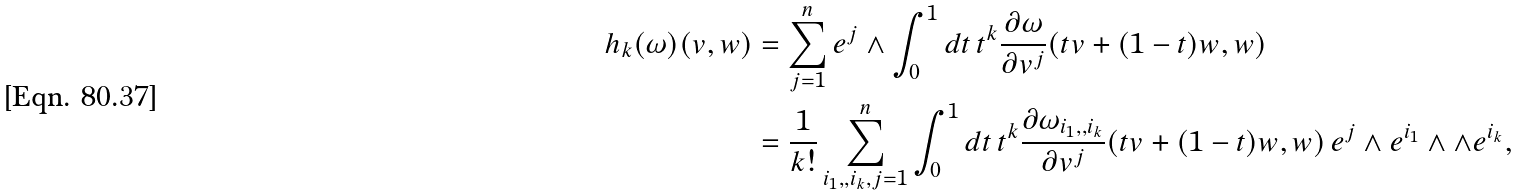Convert formula to latex. <formula><loc_0><loc_0><loc_500><loc_500>h _ { k } ( \omega ) ( v , w ) & = \sum _ { j = 1 } ^ { n } e ^ { j } \wedge \int _ { 0 } ^ { 1 } d t \, t ^ { k } \frac { \partial \omega } { \partial v ^ { j } } ( t v + ( 1 - t ) w , w ) \\ & = \frac { 1 } { k ! } \sum _ { i _ { 1 } , , i _ { k } , j = 1 } ^ { n } \int _ { 0 } ^ { 1 } d t \, t ^ { k } \frac { \partial \omega _ { i _ { 1 } , , i _ { k } } } { \partial v ^ { j } } ( t v + ( 1 - t ) w , w ) \, e ^ { j } \wedge e ^ { i _ { 1 } } \wedge \wedge e ^ { i _ { k } } ,</formula> 